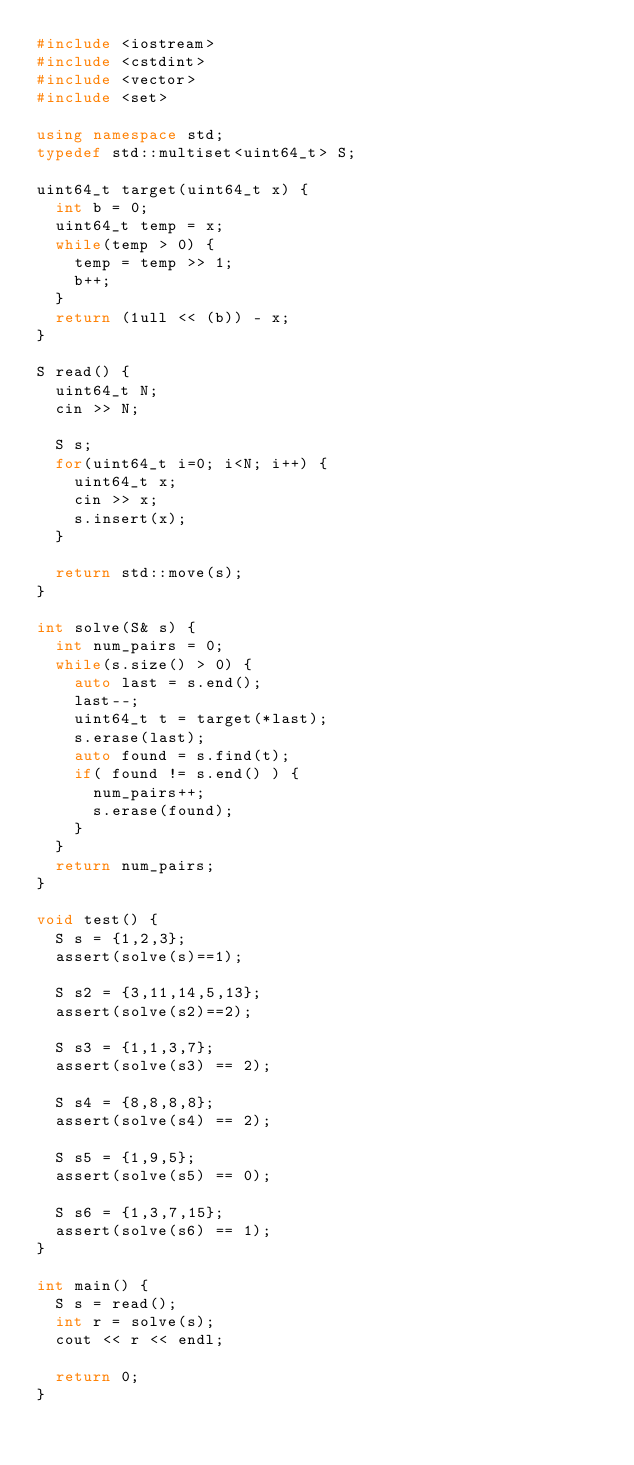<code> <loc_0><loc_0><loc_500><loc_500><_C++_>#include <iostream>
#include <cstdint>
#include <vector>
#include <set>

using namespace std;
typedef std::multiset<uint64_t> S;

uint64_t target(uint64_t x) {
  int b = 0;
  uint64_t temp = x;
  while(temp > 0) {
    temp = temp >> 1;
    b++;
  }
  return (1ull << (b)) - x;
}

S read() {
  uint64_t N;
  cin >> N;

  S s;
  for(uint64_t i=0; i<N; i++) {
    uint64_t x;
    cin >> x;
    s.insert(x);
  }

  return std::move(s);
}

int solve(S& s) {
  int num_pairs = 0;
  while(s.size() > 0) {
    auto last = s.end();
    last--;
    uint64_t t = target(*last);
    s.erase(last);
    auto found = s.find(t);
    if( found != s.end() ) {
      num_pairs++;
      s.erase(found);
    }
  }
  return num_pairs;
}

void test() {
  S s = {1,2,3};
  assert(solve(s)==1);

  S s2 = {3,11,14,5,13};
  assert(solve(s2)==2);

  S s3 = {1,1,3,7};
  assert(solve(s3) == 2);

  S s4 = {8,8,8,8};
  assert(solve(s4) == 2);

  S s5 = {1,9,5};
  assert(solve(s5) == 0);

  S s6 = {1,3,7,15};
  assert(solve(s6) == 1);
}

int main() {
  S s = read();
  int r = solve(s);
  cout << r << endl;

  return 0;
}

</code> 